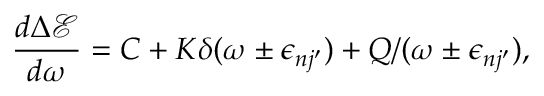<formula> <loc_0><loc_0><loc_500><loc_500>\frac { d \Delta \mathcal { E } } { d \omega } = C + K \delta ( \omega \pm \epsilon _ { n j ^ { \prime } } ) + Q / ( \omega \pm \epsilon _ { n j ^ { \prime } } ) ,</formula> 